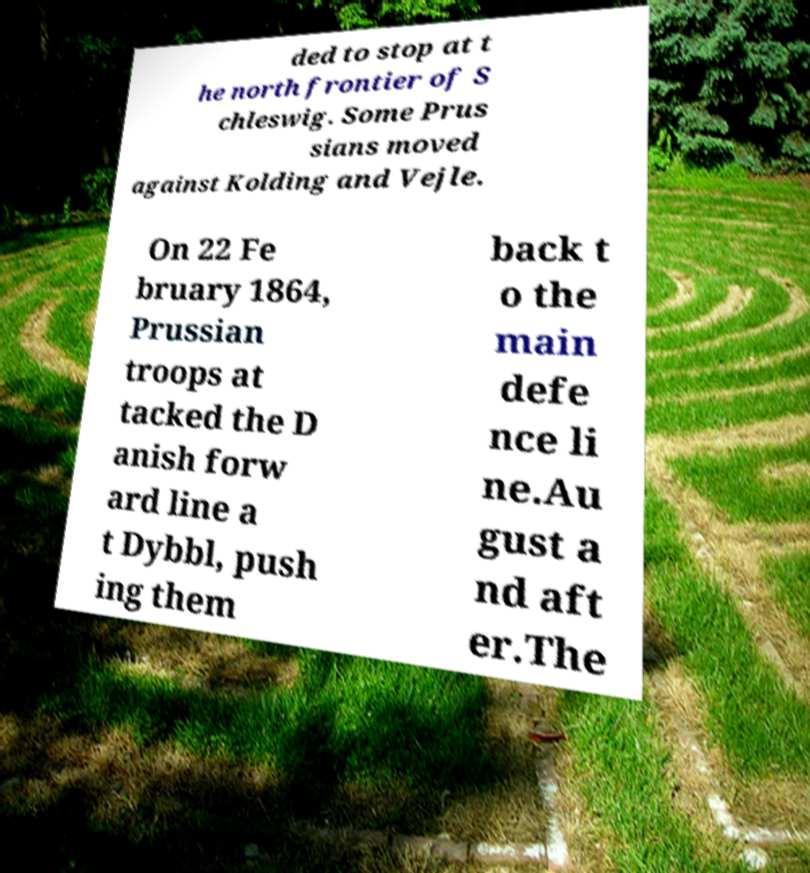Could you extract and type out the text from this image? ded to stop at t he north frontier of S chleswig. Some Prus sians moved against Kolding and Vejle. On 22 Fe bruary 1864, Prussian troops at tacked the D anish forw ard line a t Dybbl, push ing them back t o the main defe nce li ne.Au gust a nd aft er.The 